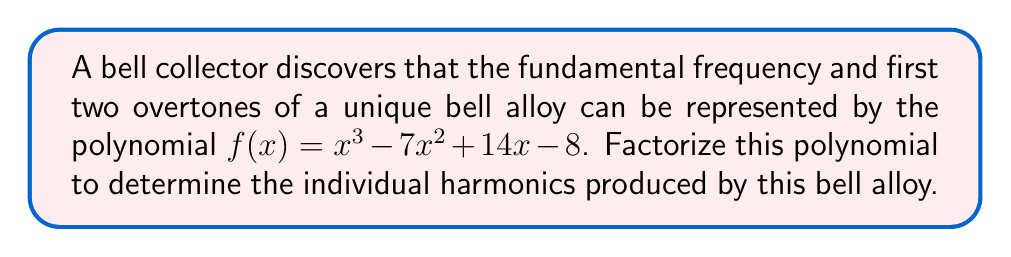Teach me how to tackle this problem. Let's approach this step-by-step:

1) First, we need to check if there are any rational roots. We can use the rational root theorem. The possible rational roots are the factors of the constant term: ±1, ±2, ±4, ±8.

2) Testing these values, we find that $f(1) = 0$. So $(x-1)$ is a factor.

3) We can use polynomial long division to divide $f(x)$ by $(x-1)$:

   $$\frac{x^3 - 7x^2 + 14x - 8}{x-1} = x^2 - 6x + 8$$

4) Now we need to factor the quadratic $x^2 - 6x + 8$. We can use the quadratic formula or factoring by grouping.

5) The quadratic can be rewritten as $(x-2)(x-4)$

6) Therefore, the complete factorization is:

   $$f(x) = (x-1)(x-2)(x-4)$$

This factorization represents the individual harmonics of the bell alloy, with each factor corresponding to a specific frequency component.
Answer: $(x-1)(x-2)(x-4)$ 